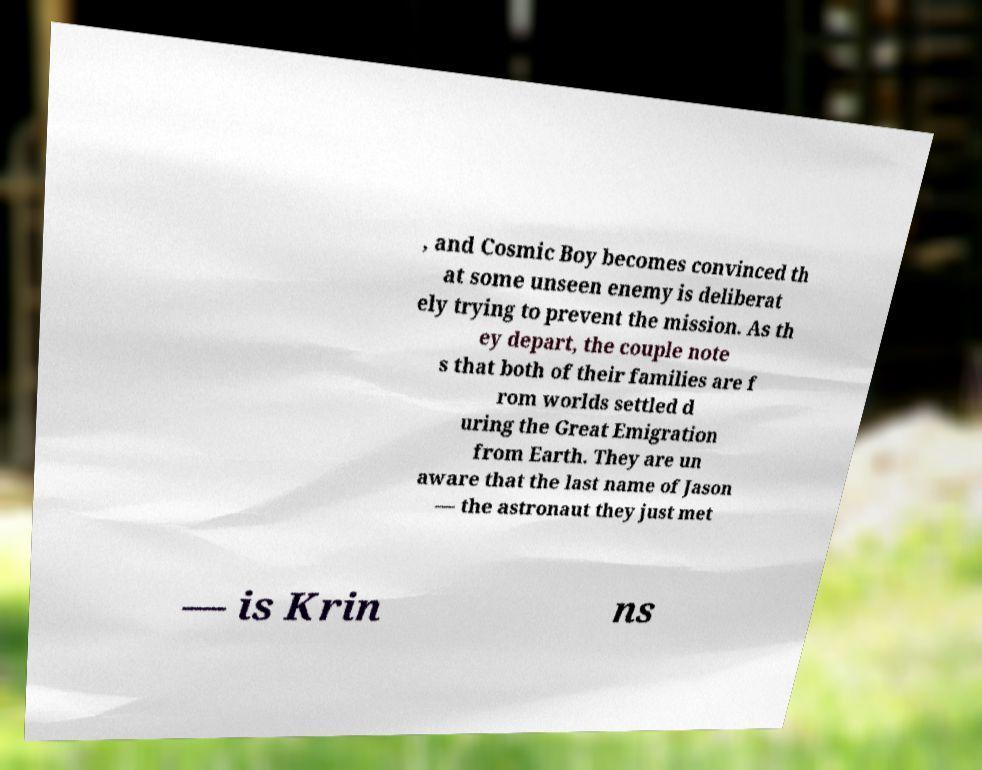There's text embedded in this image that I need extracted. Can you transcribe it verbatim? , and Cosmic Boy becomes convinced th at some unseen enemy is deliberat ely trying to prevent the mission. As th ey depart, the couple note s that both of their families are f rom worlds settled d uring the Great Emigration from Earth. They are un aware that the last name of Jason — the astronaut they just met — is Krin ns 